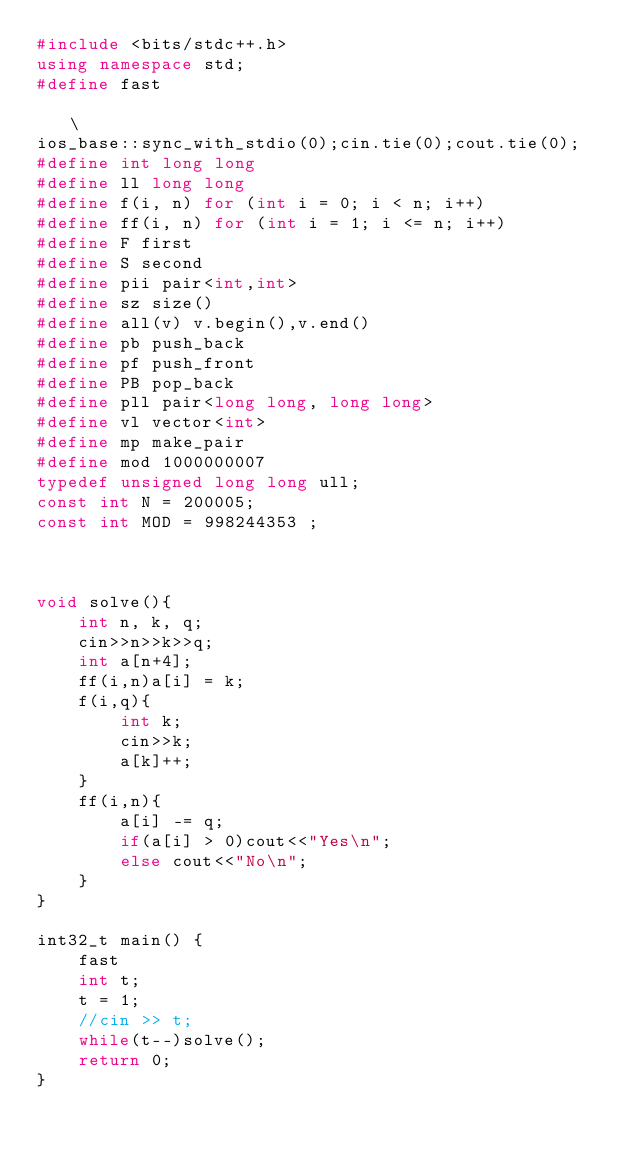<code> <loc_0><loc_0><loc_500><loc_500><_C++_>#include <bits/stdc++.h>
using namespace std;
#define fast                                                                   \
ios_base::sync_with_stdio(0);cin.tie(0);cout.tie(0);
#define int long long
#define ll long long
#define f(i, n) for (int i = 0; i < n; i++)
#define ff(i, n) for (int i = 1; i <= n; i++)
#define F first
#define S second
#define pii pair<int,int>
#define sz size()
#define all(v) v.begin(),v.end()
#define pb push_back
#define pf push_front    
#define PB pop_back
#define pll pair<long long, long long>
#define vl vector<int>
#define mp make_pair
#define mod 1000000007
typedef unsigned long long ull;
const int N = 200005;
const int MOD = 998244353 ;



void solve(){
    int n, k, q;
    cin>>n>>k>>q;
    int a[n+4];
    ff(i,n)a[i] = k;
    f(i,q){
        int k;
        cin>>k;
        a[k]++;
    }
    ff(i,n){
        a[i] -= q;
        if(a[i] > 0)cout<<"Yes\n";
        else cout<<"No\n";
    }
}

int32_t main() {
    fast
    int t;
    t = 1;
    //cin >> t;
    while(t--)solve();
    return 0;
}</code> 